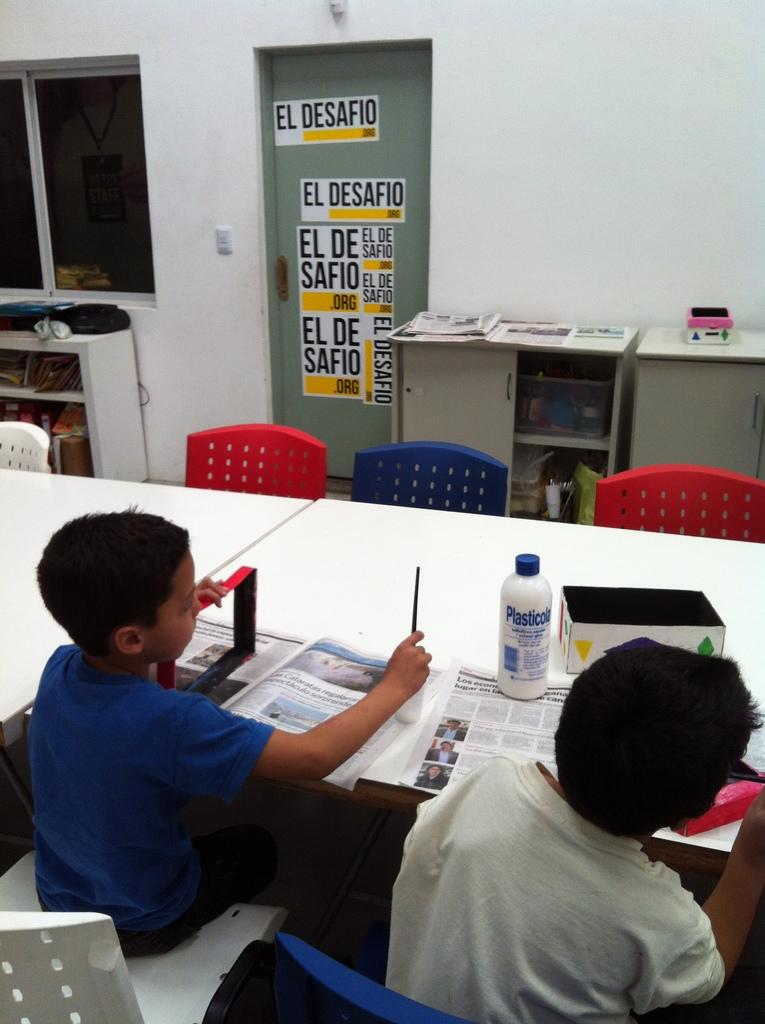Provide a one-sentence caption for the provided image. Two children sit at a table with signs on a door in the background reading EL DESAFIO. 